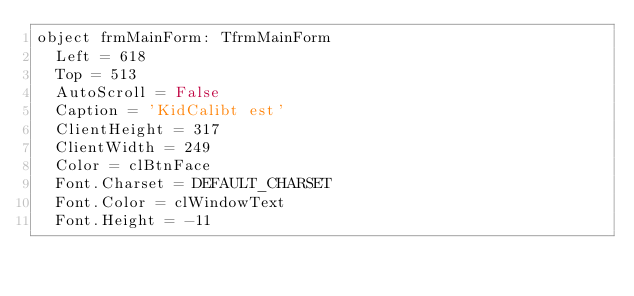<code> <loc_0><loc_0><loc_500><loc_500><_Pascal_>object frmMainForm: TfrmMainForm
  Left = 618
  Top = 513
  AutoScroll = False
  Caption = 'KidCalibt est'
  ClientHeight = 317
  ClientWidth = 249
  Color = clBtnFace
  Font.Charset = DEFAULT_CHARSET
  Font.Color = clWindowText
  Font.Height = -11</code> 